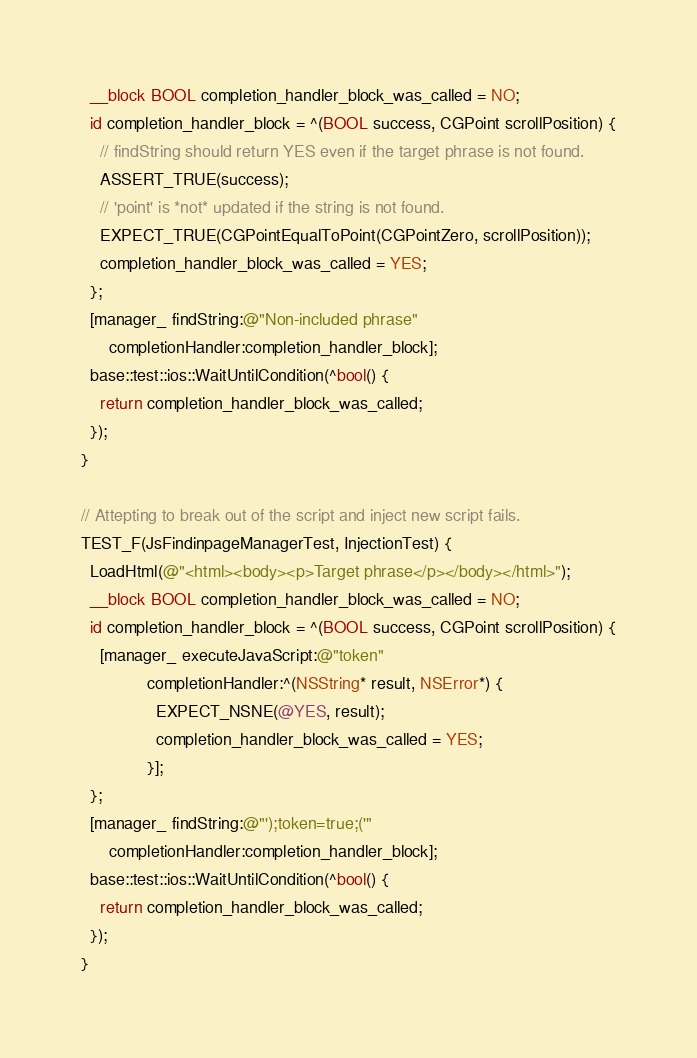Convert code to text. <code><loc_0><loc_0><loc_500><loc_500><_ObjectiveC_>  __block BOOL completion_handler_block_was_called = NO;
  id completion_handler_block = ^(BOOL success, CGPoint scrollPosition) {
    // findString should return YES even if the target phrase is not found.
    ASSERT_TRUE(success);
    // 'point' is *not* updated if the string is not found.
    EXPECT_TRUE(CGPointEqualToPoint(CGPointZero, scrollPosition));
    completion_handler_block_was_called = YES;
  };
  [manager_ findString:@"Non-included phrase"
      completionHandler:completion_handler_block];
  base::test::ios::WaitUntilCondition(^bool() {
    return completion_handler_block_was_called;
  });
}

// Attepting to break out of the script and inject new script fails.
TEST_F(JsFindinpageManagerTest, InjectionTest) {
  LoadHtml(@"<html><body><p>Target phrase</p></body></html>");
  __block BOOL completion_handler_block_was_called = NO;
  id completion_handler_block = ^(BOOL success, CGPoint scrollPosition) {
    [manager_ executeJavaScript:@"token"
              completionHandler:^(NSString* result, NSError*) {
                EXPECT_NSNE(@YES, result);
                completion_handler_block_was_called = YES;
              }];
  };
  [manager_ findString:@"');token=true;('"
      completionHandler:completion_handler_block];
  base::test::ios::WaitUntilCondition(^bool() {
    return completion_handler_block_was_called;
  });
}
</code> 